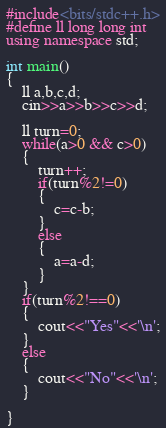Convert code to text. <code><loc_0><loc_0><loc_500><loc_500><_C++_>#include<bits/stdc++.h>
#define ll long long int
using namespace std;

int main()
{
    ll a,b,c,d;
    cin>>a>>b>>c>>d;

    ll turn=0;
    while(a>0 && c>0)
    {
        turn++;
        if(turn%2!=0)
        {
            c=c-b;
        }
        else
        {
            a=a-d;
        }
    }
    if(turn%2!==0)
    {
        cout<<"Yes"<<'\n';
    }
    else
    {
        cout<<"No"<<'\n';
    }

}</code> 